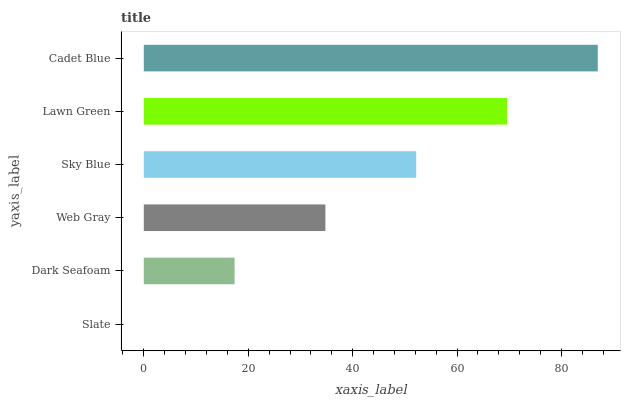Is Slate the minimum?
Answer yes or no. Yes. Is Cadet Blue the maximum?
Answer yes or no. Yes. Is Dark Seafoam the minimum?
Answer yes or no. No. Is Dark Seafoam the maximum?
Answer yes or no. No. Is Dark Seafoam greater than Slate?
Answer yes or no. Yes. Is Slate less than Dark Seafoam?
Answer yes or no. Yes. Is Slate greater than Dark Seafoam?
Answer yes or no. No. Is Dark Seafoam less than Slate?
Answer yes or no. No. Is Sky Blue the high median?
Answer yes or no. Yes. Is Web Gray the low median?
Answer yes or no. Yes. Is Web Gray the high median?
Answer yes or no. No. Is Dark Seafoam the low median?
Answer yes or no. No. 